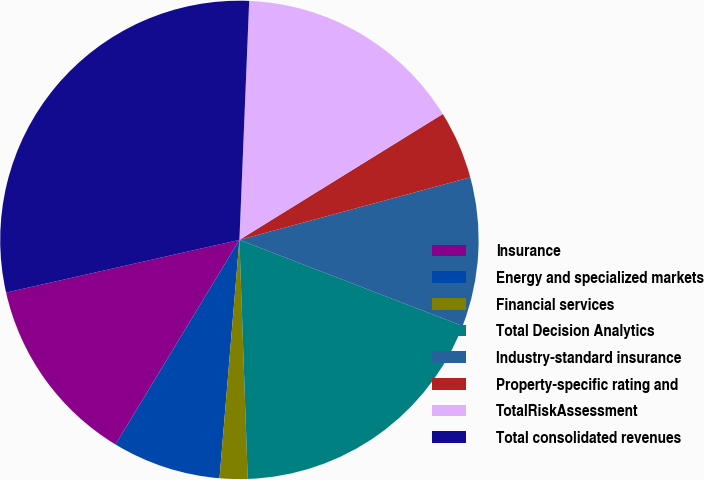Convert chart. <chart><loc_0><loc_0><loc_500><loc_500><pie_chart><fcel>Insurance<fcel>Energy and specialized markets<fcel>Financial services<fcel>Total Decision Analytics<fcel>Industry-standard insurance<fcel>Property-specific rating and<fcel>TotalRiskAssessment<fcel>Total consolidated revenues<nl><fcel>12.8%<fcel>7.34%<fcel>1.88%<fcel>18.59%<fcel>10.07%<fcel>4.61%<fcel>15.53%<fcel>29.19%<nl></chart> 